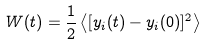Convert formula to latex. <formula><loc_0><loc_0><loc_500><loc_500>W ( t ) = \frac { 1 } { 2 } \left \langle [ y _ { i } ( t ) - y _ { i } ( 0 ) ] ^ { 2 } \right \rangle</formula> 